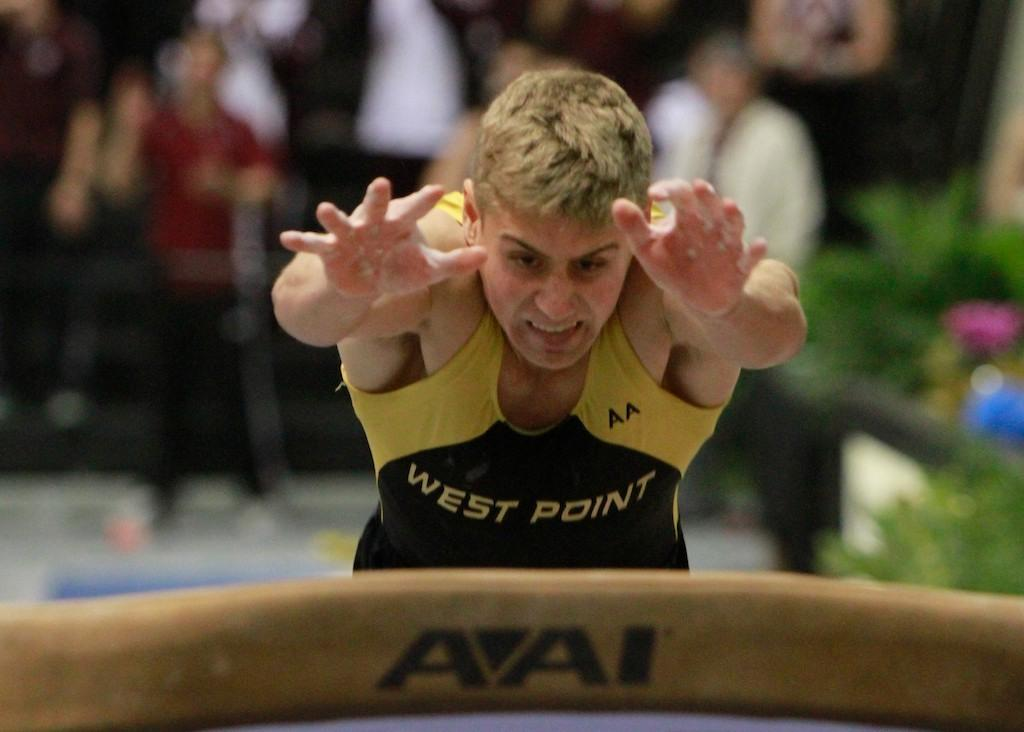What is the main action being performed by the person in the image? There is a person diving in the image. What can be seen at the bottom of the image? There is a wood at the bottom of the image. What is visible in the background of the image? There is a crowd and plants visible in the background of the image. What color of paint is being used by the person diving in the image? There is no paint or painting activity present in the image. How many volleyballs can be seen in the image? There are no volleyballs visible in the image. 